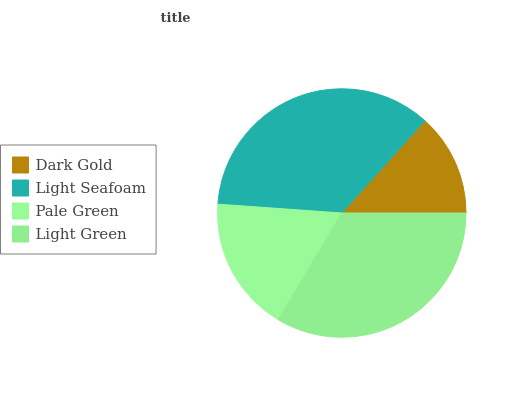Is Dark Gold the minimum?
Answer yes or no. Yes. Is Light Seafoam the maximum?
Answer yes or no. Yes. Is Pale Green the minimum?
Answer yes or no. No. Is Pale Green the maximum?
Answer yes or no. No. Is Light Seafoam greater than Pale Green?
Answer yes or no. Yes. Is Pale Green less than Light Seafoam?
Answer yes or no. Yes. Is Pale Green greater than Light Seafoam?
Answer yes or no. No. Is Light Seafoam less than Pale Green?
Answer yes or no. No. Is Light Green the high median?
Answer yes or no. Yes. Is Pale Green the low median?
Answer yes or no. Yes. Is Dark Gold the high median?
Answer yes or no. No. Is Light Seafoam the low median?
Answer yes or no. No. 